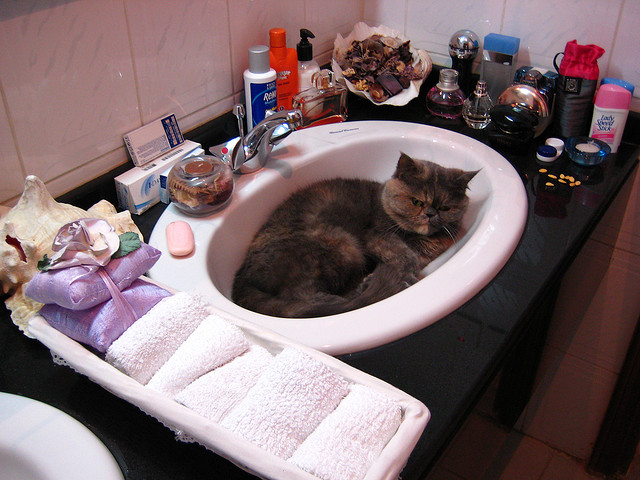Should the cat be here? It's not unusual for cats to seek out cozy spots; however, a sink isn't the ideal place for a cat due to the risk of encountering toxic substances or getting wet unintentionally. 